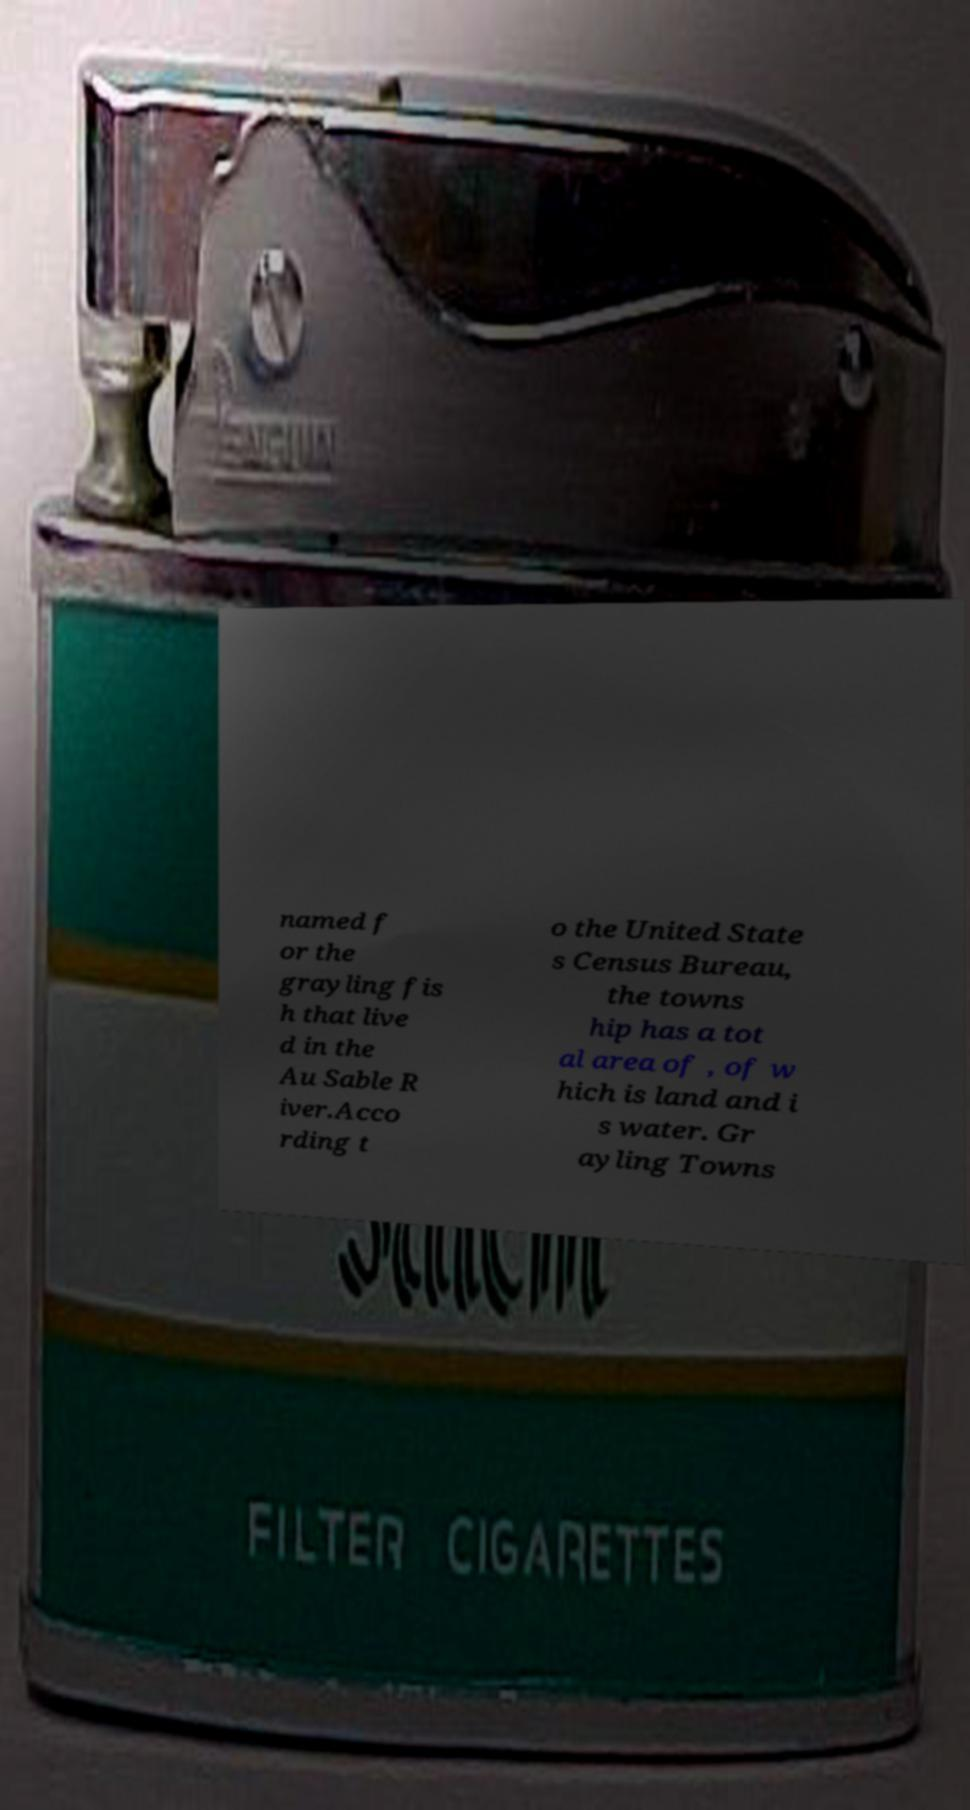There's text embedded in this image that I need extracted. Can you transcribe it verbatim? named f or the grayling fis h that live d in the Au Sable R iver.Acco rding t o the United State s Census Bureau, the towns hip has a tot al area of , of w hich is land and i s water. Gr ayling Towns 